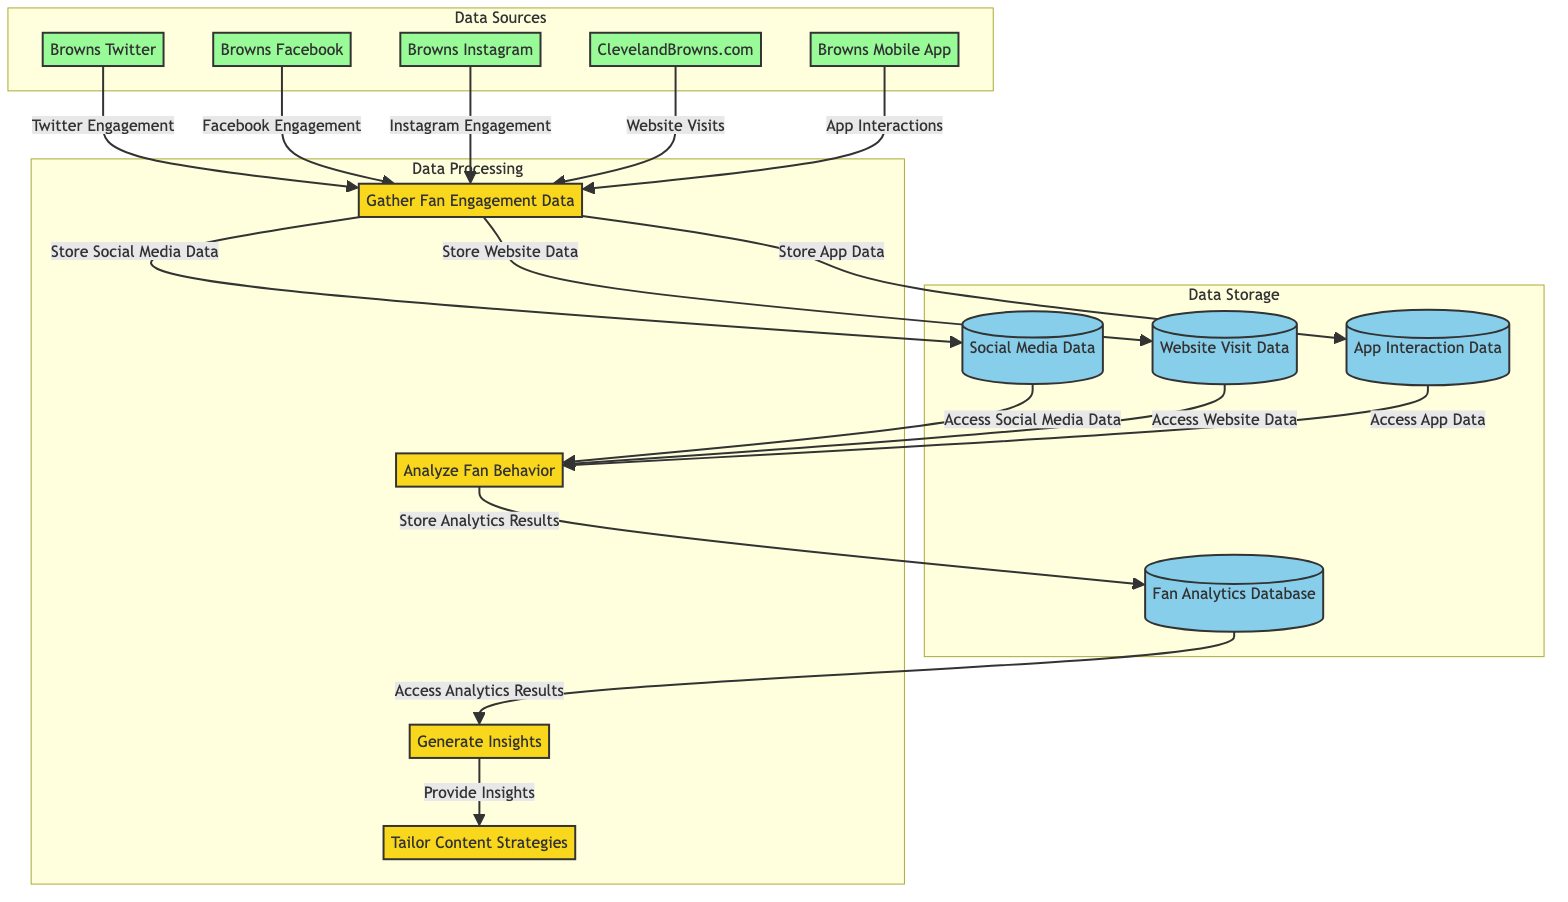What is the first process in the diagram? The first process is labeled as "Gather Fan Engagement Data," which indicates the initial step in collecting data from various fan engagement channels.
Answer: Gather Fan Engagement Data How many external entities are present in the diagram? The diagram shows a total of five external entities: Browns Twitter, Browns Facebook, Browns Instagram, ClevelandBrowns.com, and Browns Mobile App.
Answer: 5 Which data store is associated with website visit data? The data store that is specifically labeled for website visit data is "Website Visit Data," which stores the interactions and analytics results pertaining to fan engagement on the website.
Answer: Website Visit Data What is the last process in the flow? The last process in the flow diagram is "Tailor Content Strategies," which follows the generation of insights to adapt and enhance content based on fan behavior analytics.
Answer: Tailor Content Strategies What data flows from the social media data store to the analysis process? The flow from the social media data store (DS1) to the analysis process (2) is labeled "Access Social Media Data," indicating the process of utilizing the stored social media information for deeper analysis.
Answer: Access Social Media Data Which external entity provides app interactions? The external entity that provides app interactions is labeled as "Browns Mobile App," which engages fans through the mobile platform and contributes to the data collection process.
Answer: Browns Mobile App What insight is generated from the analytics results? The output from the analytic process is labeled "Provide Insights," which refers to the derived understanding of fan behavior and preferences after analyzing the collected data.
Answer: Provide Insights How many data stores are represented in the diagram? There are four data stores represented in the diagram, which include Social Media Data, Website Visit Data, App Interaction Data, and Fan Analytics Database.
Answer: 4 What is the relationship between the analyze fan behavior process and the fan analytics database? The relationship is that the Analyze Fan Behavior process (2) accesses data from the Fan Analytics Database (DS4) to conduct analysis, and also stores the results back into this database following the analysis.
Answer: Accesses and stores data 